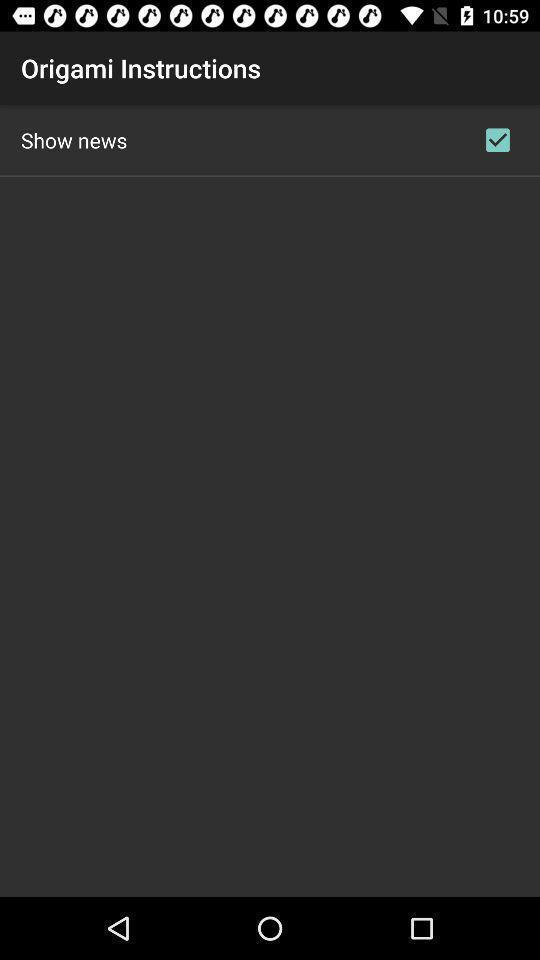Explain what's happening in this screen capture. Screen shows origami instructions. 